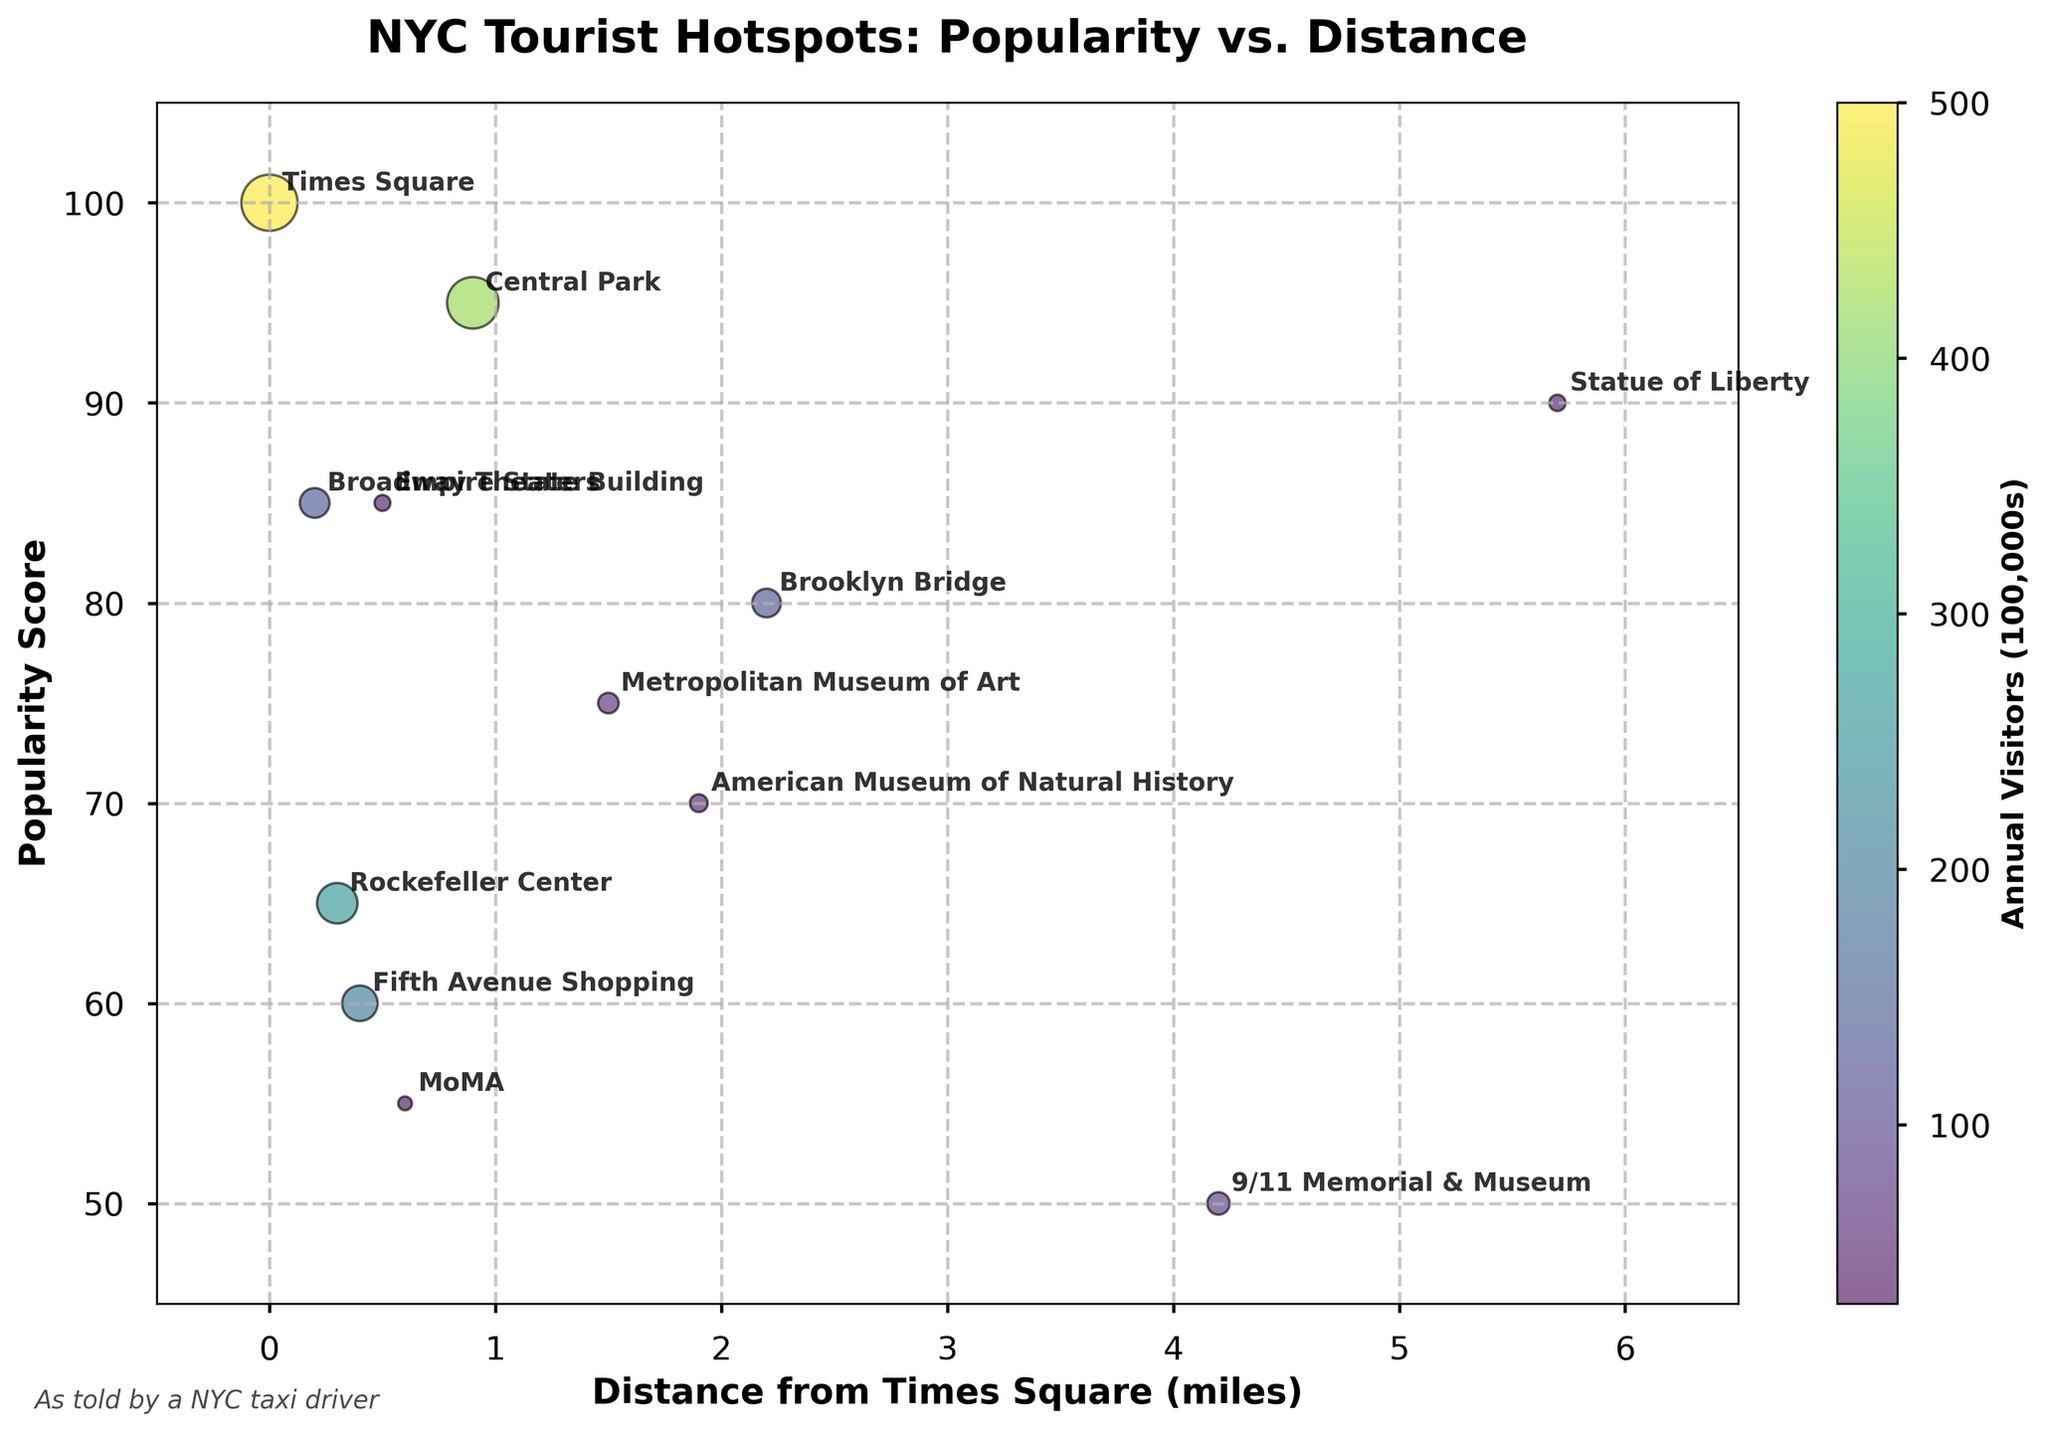What is the title of the plot? The title of the plot is clearly shown at the top of the figure, reading "NYC Tourist Hotspots: Popularity vs. Distance".
Answer: NYC Tourist Hotspots: Popularity vs. Distance How many tourist hotspots are represented in the Bubble Chart? By counting the individual bubble annotations or the bubbles present in the chart, we can see there are 12 tourist hotspots in total.
Answer: 12 Which tourist hotspot is the most popular and how far is it from Times Square? According to the plot, Times Square has the highest popularity score of 100 and is located at 0.0 miles from itself.
Answer: Times Square, 0.0 miles What is the least popular tourist hotspot shown in the chart, and what is its annual visitors count? The least popular hotspot, as indicated by the lowest popularity score, is the 9/11 Memorial & Museum with a popularity score of 50 and an annual visitors count shown by the bubble size corresponding to around 8 million visitors.
Answer: 9/11 Memorial & Museum, 8 million visitors Which tourist hotspot is located the furthest from Times Square? Referring to the X-axis which indicates distance, the Statue of Liberty is located the furthest at 5.7 miles from Times Square.
Answer: Statue of Liberty How many tourist hotspots have a popularity score of 85? There are two tourist hotspots with a popularity score of 85, namely Empire State Building and Broadway Theaters.
Answer: 2 What are the coordinates (Distance from Times Square and Popularity Score) of the American Museum of Natural History? From the plot annotations, the American Museum of Natural History is located at coordinates (1.9, 70) where 1.9 is the distance from Times Square and 70 is the popularity score.
Answer: (1.9, 70) Between Central Park and Rockefeller Center, which one is closer to Times Square? By comparing their distances from Times Square (X-axis values), Rockefeller Center is closer with a distance of 0.3 miles compared to Central Park which is 0.9 miles away.
Answer: Rockefeller Center What is the total number of annual visitors for the Metropolitan Museum of Art and MoMA combined? The annual visitors for the Metropolitan Museum of Art is 6.7 million and for MoMA is 3 million. Adding these together gives a total of 6.7 + 3 = 9.7 million visitors.
Answer: 9.7 million visitors What is the average popularity score of all the tourist hotspots located within 1 mile from Times Square? The hotspots within 1 mile are Times Square (100), Empire State Building (85), Rockefeller Center (65), Fifth Avenue Shopping (60), and MoMA (55). The average is calculated by (100 + 85 + 65 + 60 + 55) / 5 = 73.
Answer: 73 